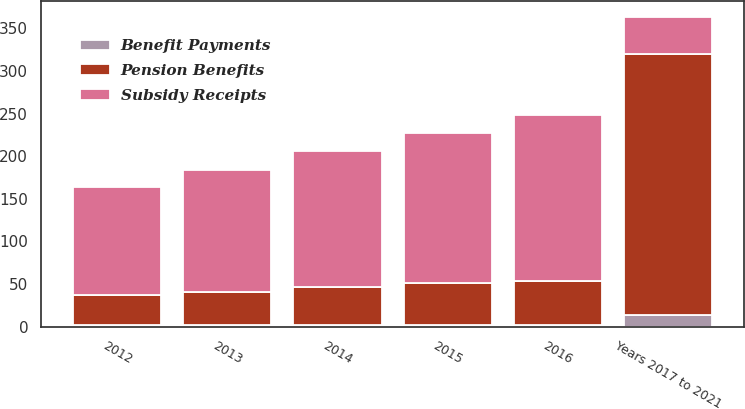Convert chart to OTSL. <chart><loc_0><loc_0><loc_500><loc_500><stacked_bar_chart><ecel><fcel>2012<fcel>2013<fcel>2014<fcel>2015<fcel>2016<fcel>Years 2017 to 2021<nl><fcel>Subsidy Receipts<fcel>127<fcel>143<fcel>160<fcel>176<fcel>194<fcel>44<nl><fcel>Pension Benefits<fcel>35<fcel>39<fcel>44<fcel>49<fcel>52<fcel>306<nl><fcel>Benefit Payments<fcel>2<fcel>2<fcel>2<fcel>2<fcel>2<fcel>14<nl></chart> 